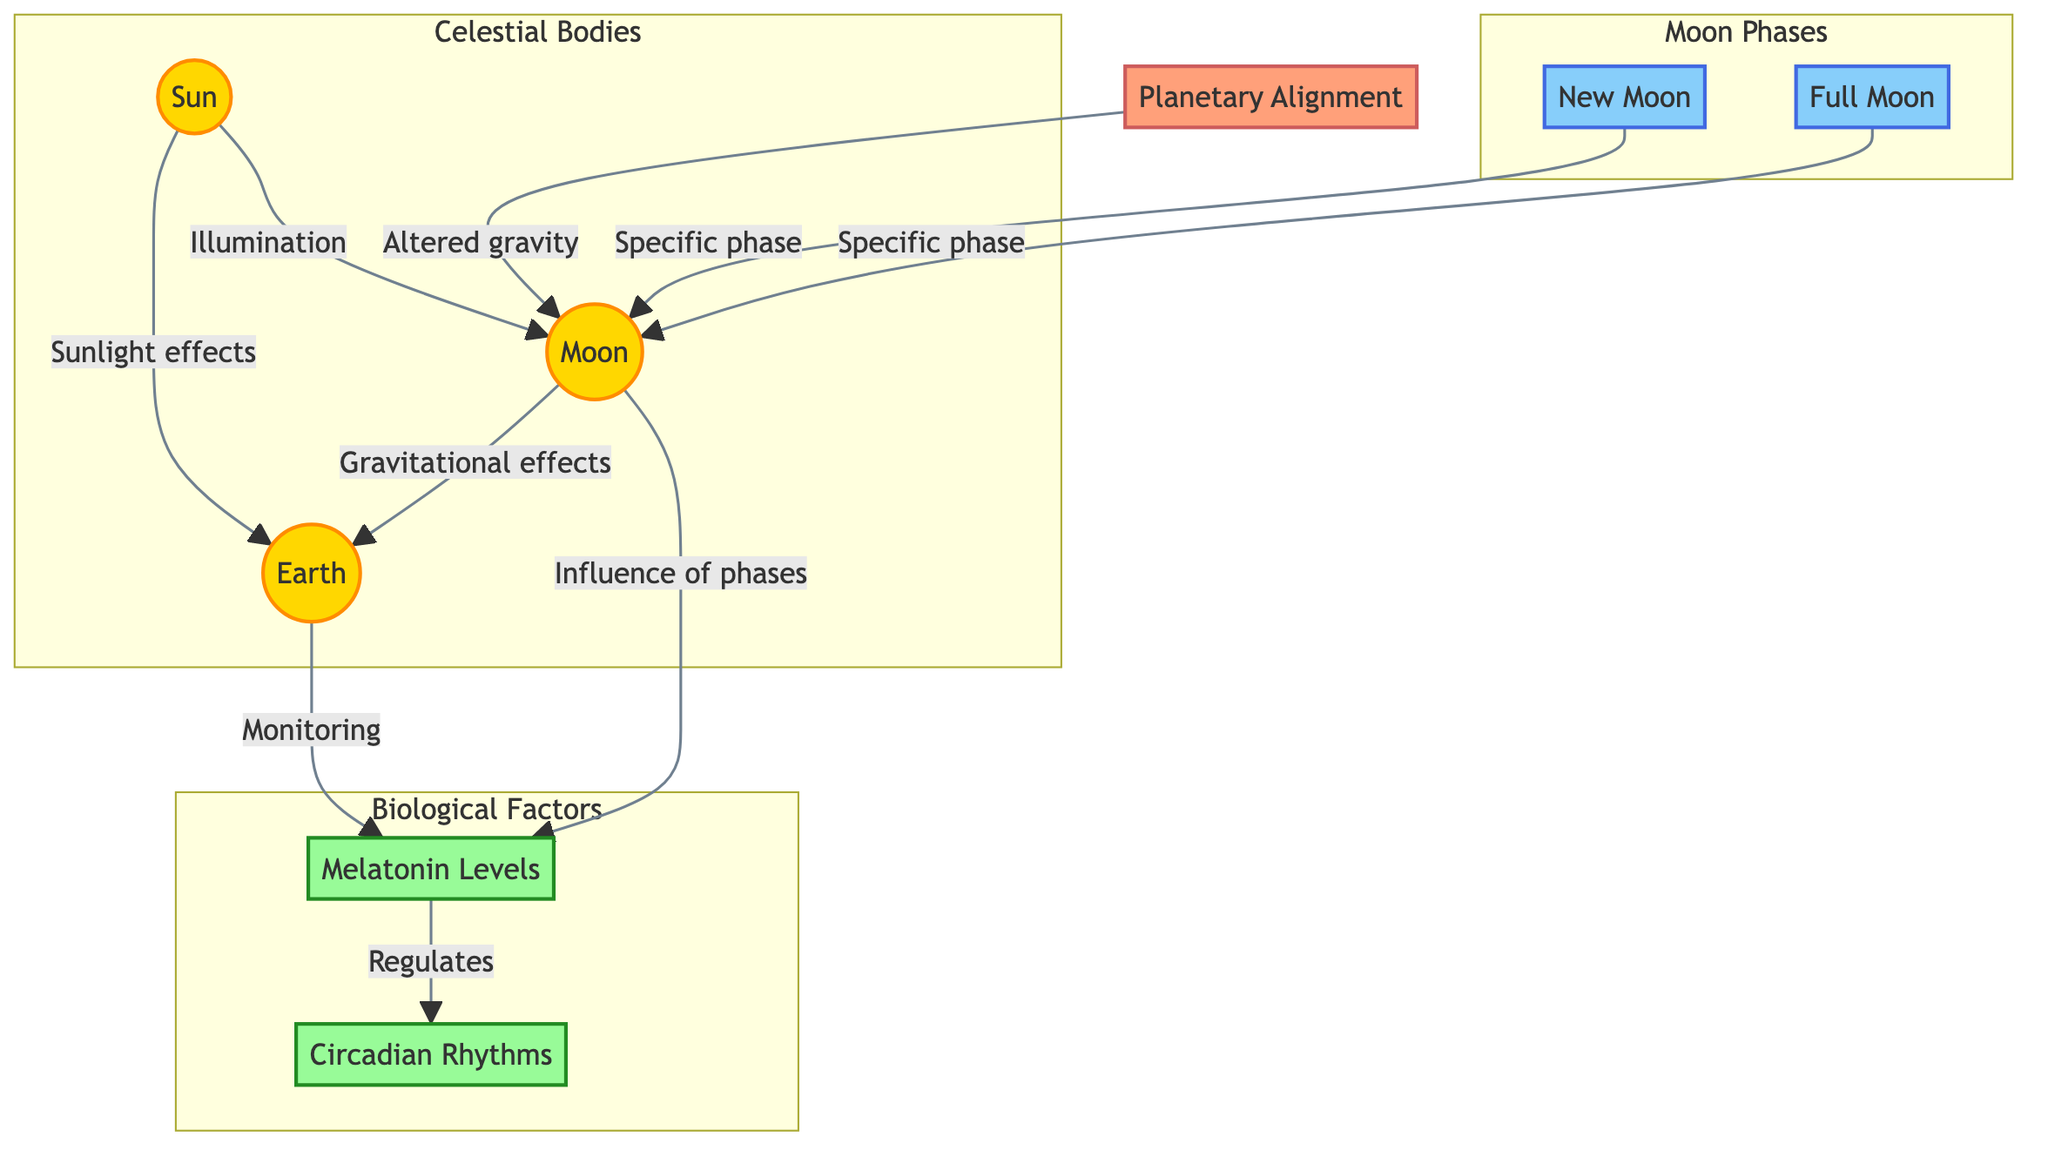What are the two main phases of the Moon depicted in the diagram? The diagram specifically illustrates two phases of the Moon: New Moon and Full Moon. These are clearly labeled within the "Moon Phases" subgraph.
Answer: New Moon, Full Moon How does the Moon influence melatonin levels? The diagram indicates that the Moon has an "Influence of phases" on Melatonin Levels, showing that different phases can affect melatonin production.
Answer: Influence of phases What does "Planetary Alignment" alter according to the diagram? The diagram connects Planetary Alignment to "Altered gravity," suggesting that these alignments may have an impact on gravitational effects, which in turn influence the Moon.
Answer: Altered gravity Which celestial body does sunlight directly affect in the context of this diagram? The diagram shows an arrow indicating that sunlight effects the Earth, connecting it directly from the Sun to the Earth.
Answer: Earth How many nodes depict biological factors in the diagram? Reviewing the diagram, there are two biological factors depicted: Melatonin Levels and Circadian Rhythms, resulting in a total count of two nodes.
Answer: 2 What role does melatonin have in relation to circadian rhythms? According to the diagram, Melatonin Levels "Regulates" Circadian Rhythms, indicating a direct regulatory relationship between the two.
Answer: Regulates What effect does the Moon have on Earth as represented in the diagram? The diagram shows the Moon's gravitational effects on Earth, indicating that the Moon influences conditions on Earth through gravitational forces.
Answer: Gravitational effects What color represents the celestial bodies in the diagram? The nodes representing celestial bodies—Sun, Earth, and Moon—are filled with a gold color, specifically defined in the diagram as "#FFD700."
Answer: Gold 